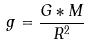<formula> <loc_0><loc_0><loc_500><loc_500>g = \frac { G * M } { R ^ { 2 } }</formula> 